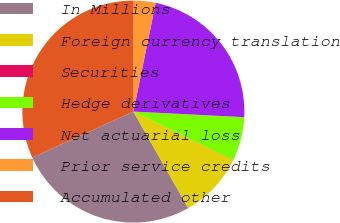<chart> <loc_0><loc_0><loc_500><loc_500><pie_chart><fcel>In Millions<fcel>Foreign currency translation<fcel>Securities<fcel>Hedge derivatives<fcel>Net actuarial loss<fcel>Prior service credits<fcel>Accumulated other<nl><fcel>26.43%<fcel>9.56%<fcel>0.03%<fcel>6.38%<fcel>22.58%<fcel>3.21%<fcel>31.81%<nl></chart> 